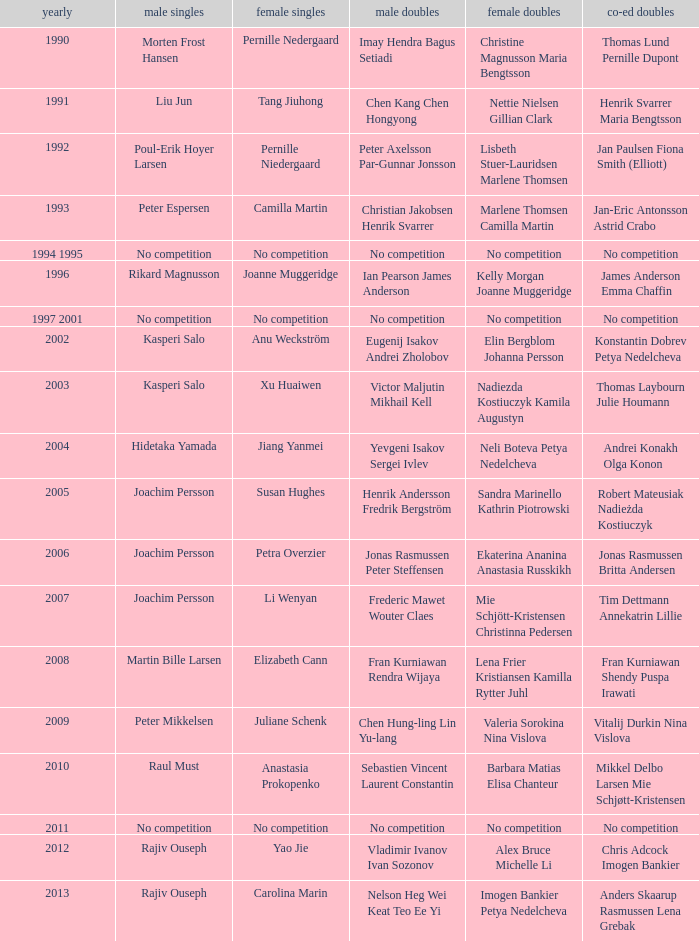What year did Carolina Marin win the Women's singles? 2013.0. 